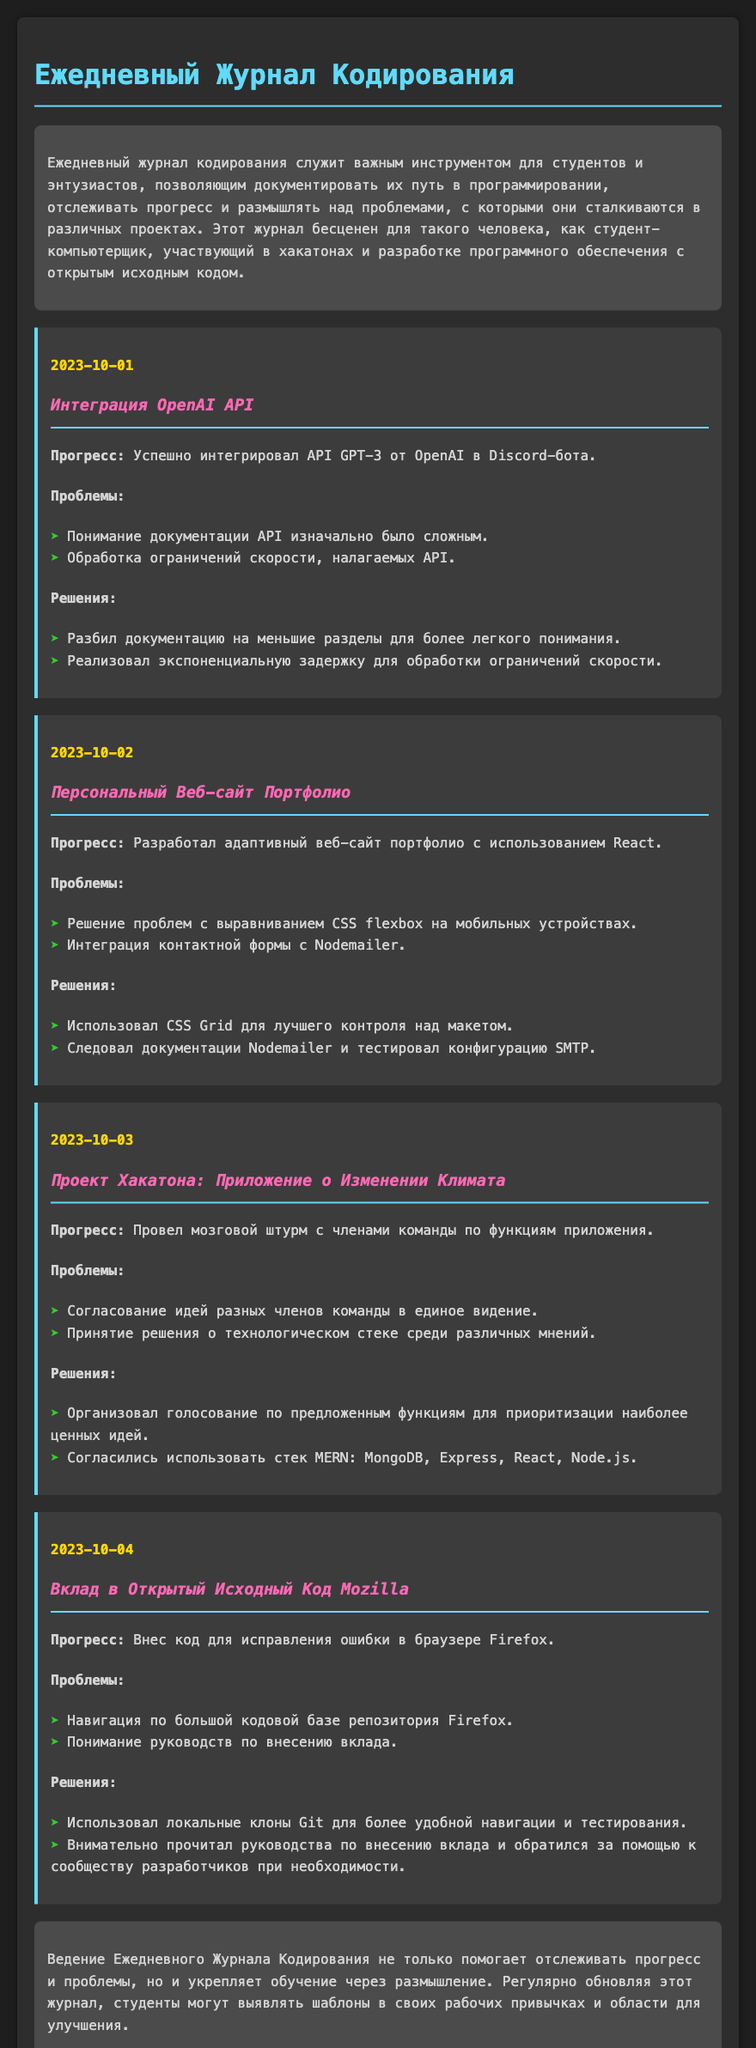что за проект был интегрирован 1 октября? Проект, интегрированный 1 октября, называется "Интеграция OpenAI API".
Answer: Интеграция OpenAI API в какой технологии был разработан персональный веб-сайт портфолио? Персональный веб-сайт портфолио был разработан с использованием React.
Answer: React какая проблема была связана с контактной формой? Проблема заключалась в интеграции контактной формы с Nodemailer.
Answer: интеграция контактной формы с Nodemailer какой стек технологий был согласован для проекта хакатона? Согласованный стек технологий для проекта хакатона - MERN.
Answer: MERN что было внесено в Firefox 4 октября? В 4 октября был внесен код для исправления ошибки в браузере Firefox.
Answer: код для исправления ошибки как часто обновляется журнал кодирования? Журнал кодирования обновляется регулярно для отслеживания прогресса.
Answer: регулярно что помогает выявить в рабочих привычках студентов? Ведение журнала помогает выявить шаблоны в рабочих привычках студентов.
Answer: шаблоны каков основной цвет текста в журнале? Основной цвет текста в журнале - д4д4д4.
Answer: д4д4д4 о чем говорит заключительная часть журнала? Заключительная часть журнала подчеркивает важность размышлений для обучения.
Answer: важность размышлений 